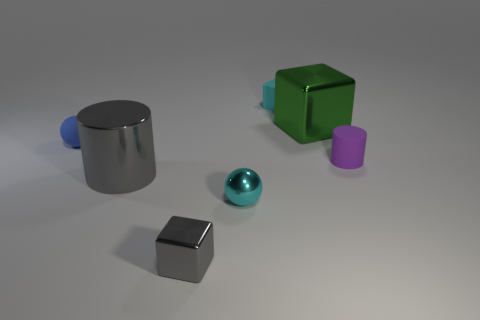Subtract all green cubes. How many cubes are left? 2 Add 3 small shiny blocks. How many objects exist? 10 Subtract all balls. How many objects are left? 5 Add 5 gray blocks. How many gray blocks exist? 6 Subtract 0 red blocks. How many objects are left? 7 Subtract all large metal cylinders. Subtract all large gray objects. How many objects are left? 5 Add 1 big cylinders. How many big cylinders are left? 2 